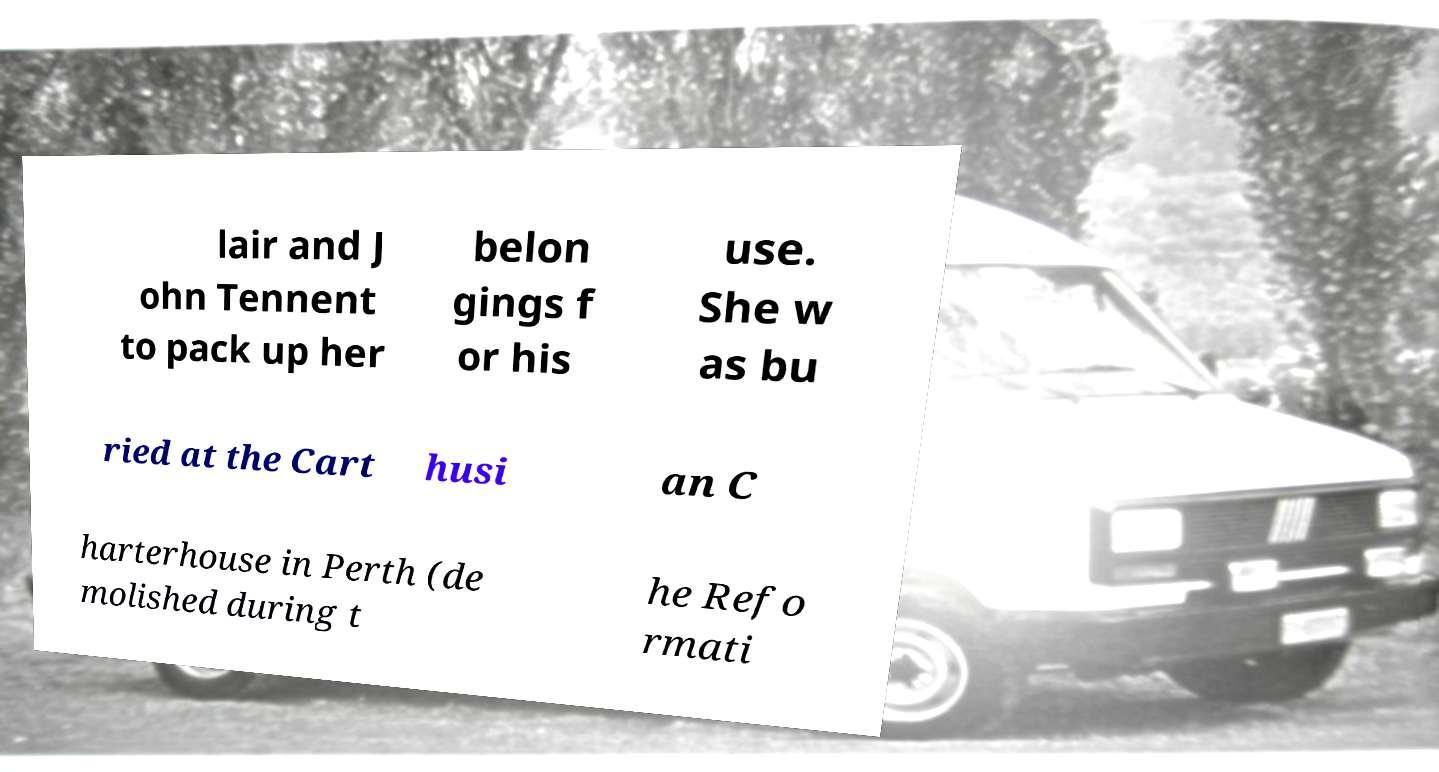There's text embedded in this image that I need extracted. Can you transcribe it verbatim? lair and J ohn Tennent to pack up her belon gings f or his use. She w as bu ried at the Cart husi an C harterhouse in Perth (de molished during t he Refo rmati 